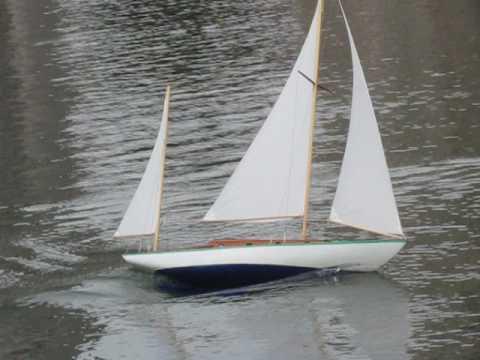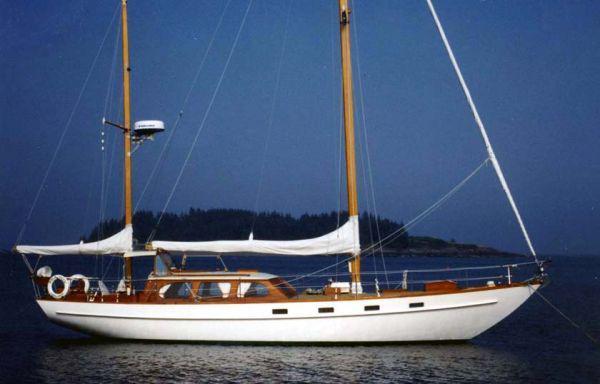The first image is the image on the left, the second image is the image on the right. Examine the images to the left and right. Is the description "One image shows a boat that is not in a body of water." accurate? Answer yes or no. No. 